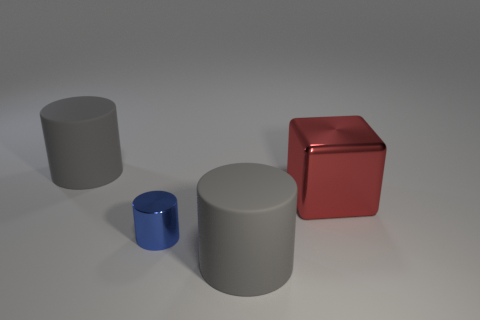Are there any other things that have the same size as the shiny cylinder?
Your answer should be very brief. No. Do the big red block and the gray cylinder that is to the right of the small blue shiny object have the same material?
Provide a succinct answer. No. Are there more tiny cylinders on the left side of the large cube than large cubes that are in front of the blue metallic object?
Provide a short and direct response. Yes. What is the shape of the red thing?
Make the answer very short. Cube. Is the large gray cylinder that is behind the metallic block made of the same material as the tiny blue object that is to the left of the large red thing?
Offer a very short reply. No. There is a big rubber object left of the small blue thing; what shape is it?
Provide a succinct answer. Cylinder. Does the large shiny block have the same color as the tiny metal cylinder?
Your response must be concise. No. Is there anything else that has the same shape as the big red object?
Provide a succinct answer. No. There is a gray object on the left side of the blue metallic cylinder; is there a tiny cylinder that is to the left of it?
Make the answer very short. No. How many other rubber things are the same color as the small thing?
Provide a succinct answer. 0. 